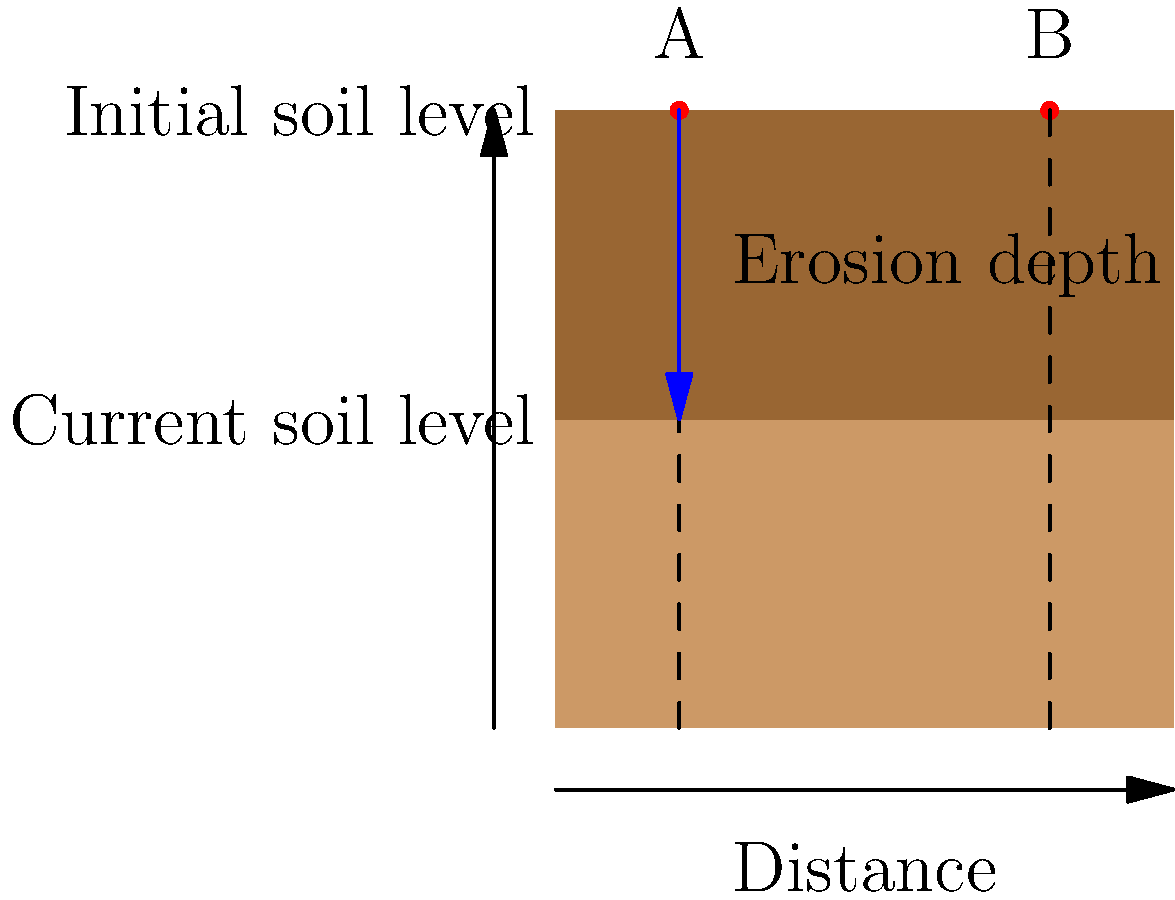Using the cross-sectional diagram of soil erosion in an area adjacent to the wildlife park, how would you calculate the average erosion rate (in cm/year) between points A and B if the measurement was taken over a 5-year period? To calculate the average erosion rate, we need to follow these steps:

1. Identify the erosion depth:
   From the diagram, we can see that the erosion depth is the difference between the initial soil level and the current soil level.

2. Measure the erosion depth:
   Let's assume the scale of the diagram is such that the erosion depth is 50 cm.

3. Calculate the average erosion depth between points A and B:
   Since the erosion depth appears to be constant between A and B, we can use the single measurement of 50 cm.

4. Determine the time period:
   The question states that the measurement was taken over a 5-year period.

5. Calculate the average erosion rate:
   Average erosion rate = Erosion depth / Time period
   $$ \text{Average erosion rate} = \frac{50 \text{ cm}}{5 \text{ years}} = 10 \text{ cm/year} $$

6. Express the result:
   The average erosion rate is 10 cm/year.

This calculation provides a quantitative measure of how quickly the soil is being eroded in the area adjacent to the wildlife park, which is crucial information for a concerned property owner to assess the impact on the surrounding ecosystem.
Answer: 10 cm/year 